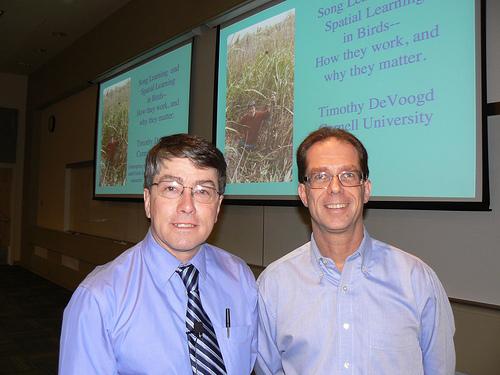How many men are in the room?
Quick response, please. 2. How many images in picture?
Answer briefly. 2. Are both men looking at the camera?
Short answer required. Yes. How many screens are visible?
Be succinct. 2. What company is this display for?
Answer briefly. Cornell university. Is one of these men bald?
Write a very short answer. No. What color are their shirts?
Keep it brief. Blue. Is it sunny?
Answer briefly. No. Are all the men wearing ties?
Give a very brief answer. No. Are these businessmen?
Concise answer only. Yes. What color is the man's tie?
Be succinct. Blue. What are the men wearing?
Give a very brief answer. Glasses. 